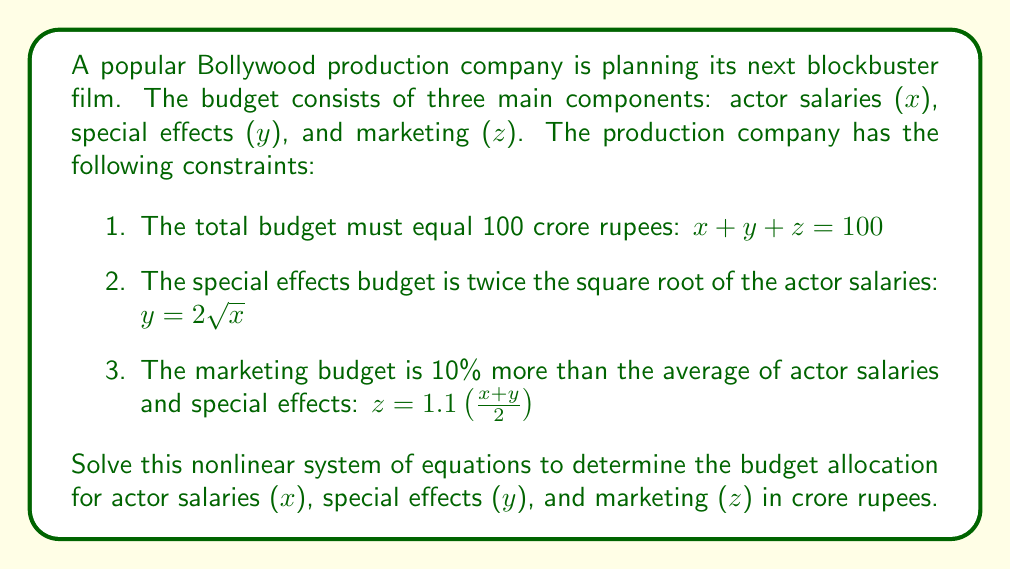Provide a solution to this math problem. Let's solve this system of nonlinear equations step by step:

1) We have three equations:
   $$x + y + z = 100$$
   $$y = 2\sqrt{x}$$
   $$z = 1.1(\frac{x+y}{2})$$

2) Substitute the second equation into the third:
   $$z = 1.1(\frac{x+2\sqrt{x}}{2})$$

3) Now substitute both of these into the first equation:
   $$x + 2\sqrt{x} + 1.1(\frac{x+2\sqrt{x}}{2}) = 100$$

4) Simplify:
   $$x + 2\sqrt{x} + 0.55x + 1.1\sqrt{x} = 100$$
   $$1.55x + 3.1\sqrt{x} = 100$$

5) Let $u = \sqrt{x}$. Then $x = u^2$, and our equation becomes:
   $$1.55u^2 + 3.1u - 100 = 0$$

6) This is a quadratic equation in $u$. We can solve it using the quadratic formula:
   $$u = \frac{-3.1 \pm \sqrt{3.1^2 + 4(1.55)(100)}}{2(1.55)}$$

7) Simplify:
   $$u = \frac{-3.1 \pm \sqrt{9.61 + 620}}{3.1} = \frac{-3.1 \pm \sqrt{629.61}}{3.1}$$
   $$u = \frac{-3.1 \pm 25.09}{3.1}$$

8) This gives us two solutions for $u$:
   $$u_1 = 7.09 \text{ and } u_2 = -9.09$$

9) Since $u = \sqrt{x}$, we can discard the negative solution. Therefore:
   $$x = 7.09^2 \approx 50.27$$

10) Now we can find $y$ and $z$:
    $$y = 2\sqrt{x} = 2(7.09) \approx 14.18$$
    $$z = 100 - x - y \approx 35.55$$

11) Round to two decimal places for the final answer.
Answer: $x \approx 50.27$, $y \approx 14.18$, $z \approx 35.55$ crore rupees 